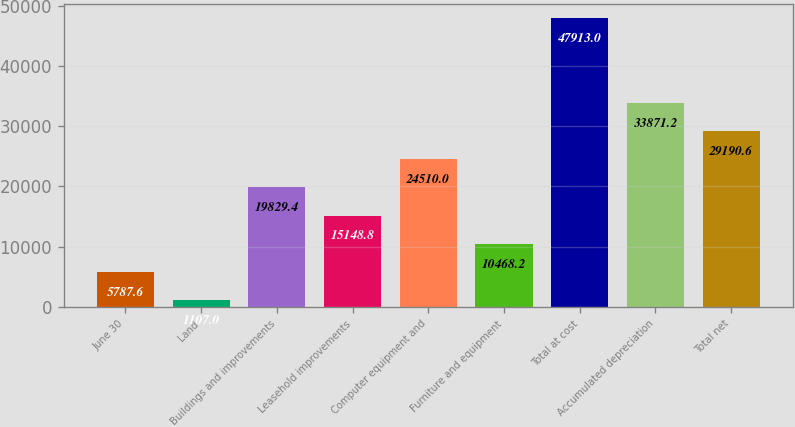Convert chart to OTSL. <chart><loc_0><loc_0><loc_500><loc_500><bar_chart><fcel>June 30<fcel>Land<fcel>Buildings and improvements<fcel>Leasehold improvements<fcel>Computer equipment and<fcel>Furniture and equipment<fcel>Total at cost<fcel>Accumulated depreciation<fcel>Total net<nl><fcel>5787.6<fcel>1107<fcel>19829.4<fcel>15148.8<fcel>24510<fcel>10468.2<fcel>47913<fcel>33871.2<fcel>29190.6<nl></chart> 